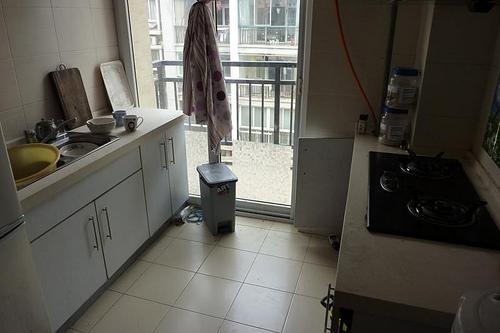Question: how many burners are on the stove?
Choices:
A. Four.
B. One.
C. Six.
D. Two.
Answer with the letter. Answer: D Question: where was the picture taken?
Choices:
A. A dining room.
B. A restaurant.
C. A kitchen.
D. An apartment.
Answer with the letter. Answer: C Question: where is the trash can sitting?
Choices:
A. In the corner.
B. Near the post.
C. On the ground.
D. Beneath the sign.
Answer with the letter. Answer: C Question: what color is the stove?
Choices:
A. White.
B. Silver.
C. Black.
D. Blue.
Answer with the letter. Answer: C 